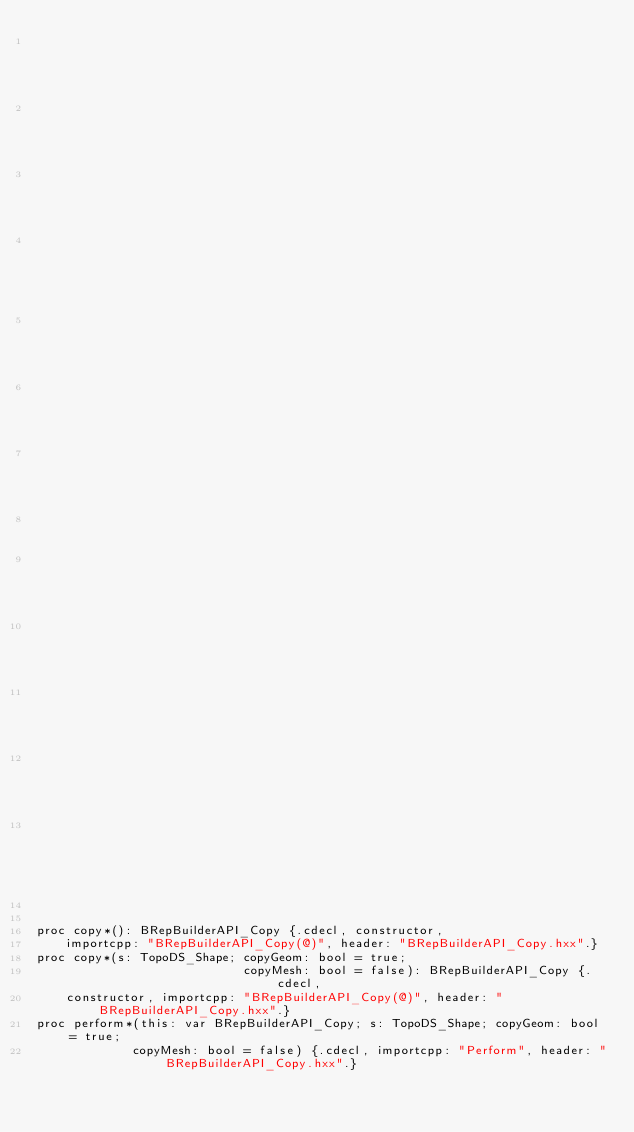Convert code to text. <code><loc_0><loc_0><loc_500><loc_500><_Nim_>                                                                                                    ## an
                                                                                                    ## empty
                                                                                                    ## copy
                                                                                                    ## framework.
                                                                                                    ## Use
                                                                                                    ## the
                                                                                                    ## function
                                                                                                    ##
                                                                                                    ## !
                                                                                                    ## Perform
                                                                                                    ## to
                                                                                                    ## copy
                                                                                                    ## shapes.


proc copy*(): BRepBuilderAPI_Copy {.cdecl, constructor,
    importcpp: "BRepBuilderAPI_Copy(@)", header: "BRepBuilderAPI_Copy.hxx".}
proc copy*(s: TopoDS_Shape; copyGeom: bool = true;
                            copyMesh: bool = false): BRepBuilderAPI_Copy {.cdecl,
    constructor, importcpp: "BRepBuilderAPI_Copy(@)", header: "BRepBuilderAPI_Copy.hxx".}
proc perform*(this: var BRepBuilderAPI_Copy; s: TopoDS_Shape; copyGeom: bool = true;
             copyMesh: bool = false) {.cdecl, importcpp: "Perform", header: "BRepBuilderAPI_Copy.hxx".}</code> 